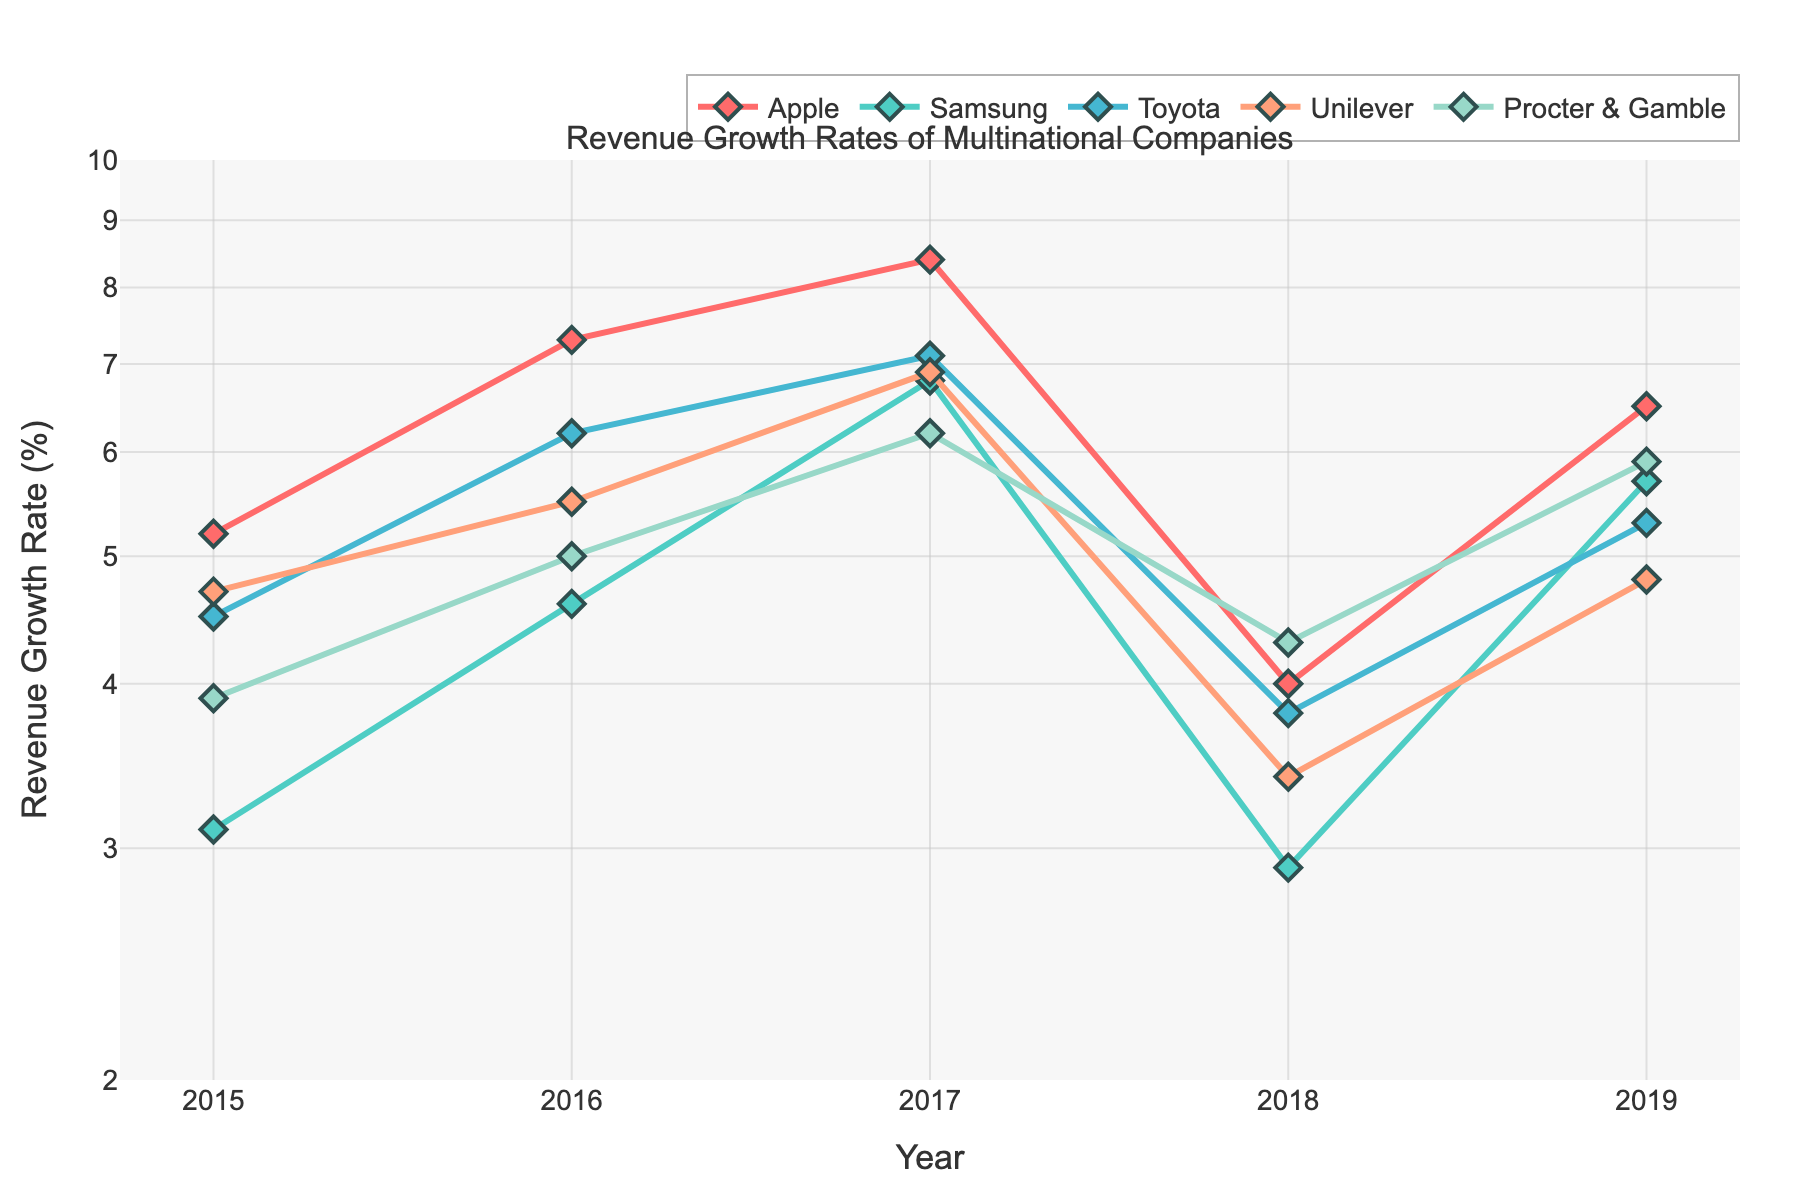Which company had the highest revenue growth rate in 2017? All companies have a data point in 2017. Apple had the highest growth rate, plotted around 8.4, higher than any other growth rates shown for 2017.
Answer: Apple What is the revenue growth rate trend for Procter & Gamble from 2015 to 2019? By looking at the curve for Procter & Gamble (identified by its color and diamond markers), their growth rates increase from 3.9% in 2015, peaking at 6.2% in 2017, and finishing at 5.9% in 2019.
Answer: Increasing trend Which two companies had the closest revenue growth rates in 2019? By comparing the endpoint values for each company in 2019, Samsung and Toyota both have growth rates near 5.7% and 5.3% respectively, making them the closest.
Answer: Samsung and Toyota During which year did Unilever experience its highest revenue growth rate? By observing the curve for Unilever across the years, in 2017, its growth rate is the highest at approximately 6.9%.
Answer: 2017 What is the average revenue growth rate for Toyota over the given years? Toyota's rates across the years are 4.5%, 6.2%, 7.1%, 3.8%, and 5.3%. Summing these: 4.5 + 6.2 + 7.1 + 3.8 + 5.3 = 26.9, and dividing by 5, the average is 26.9/5.
Answer: 5.38% How does the revenue growth rate of Samsung in 2018 compare to its rate in 2015? Samsung's rates were 2.9% in 2018 and 3.1% in 2015. Comparing the values, the rate decreased from 2015 to 2018.
Answer: Decreased Which company saw the most volatile change in revenue growth rates between consecutive years? Volatility can be observed by the steepness of changes year to year. Unilever shows a prominent drop from 2017 to 2018 and more variability across the years.
Answer: Unilever How does the revenue growth rate of Apple in 2019 compare to Toyota's in the same year? Apple's growth rate in 2019 is 6.5% compared to Toyota's 5.3%. Hence, Apple's is higher.
Answer: Apple is higher Is there a general trend in the revenue growth rates of all companies over the years? By visually assessing all curves, there is no single apparent trend; some fluctuations and varying patterns appear throughout the years.
Answer: No clear trend What range of years is used in the plot? By examining the x-axis, the range of years starts from 2015 and ends at 2019.
Answer: 2015 to 2019 